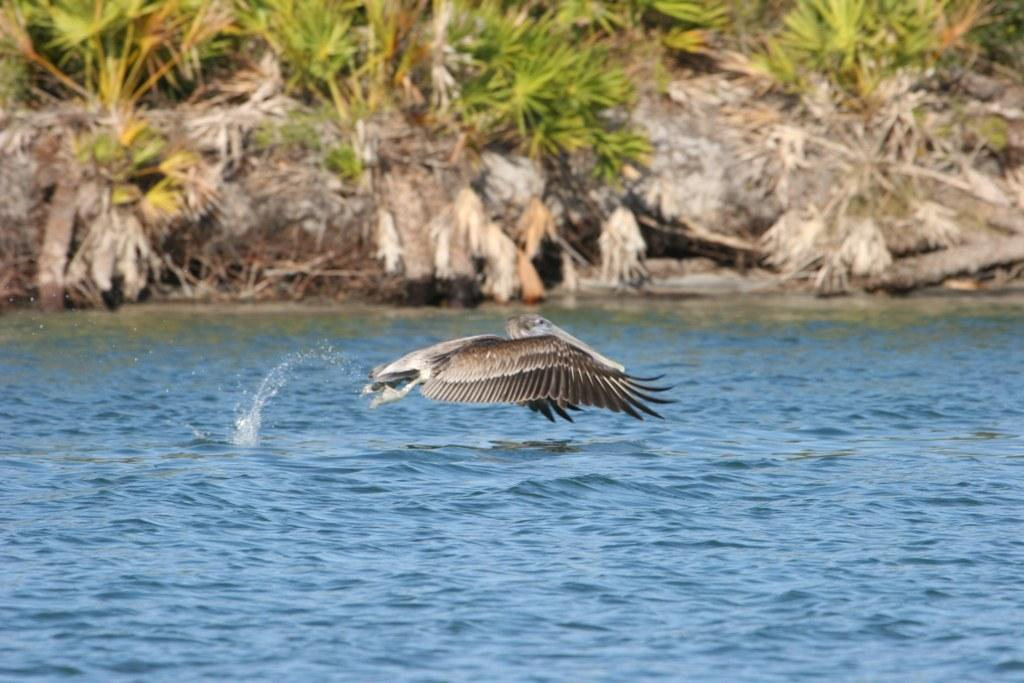What is located at the bottom of the image? There is a river at the bottom of the image. What is happening in the center of the image? There is a bird flying in the center of the image. What can be seen in the background of the image? There are trees, dry plants, and sticks in the background of the image. What type of underwear is the bird wearing in the image? There is no underwear present in the image, and birds do not wear clothing. What country is depicted in the image? The image does not depict a specific country; it features a bird, a river, and vegetation. 